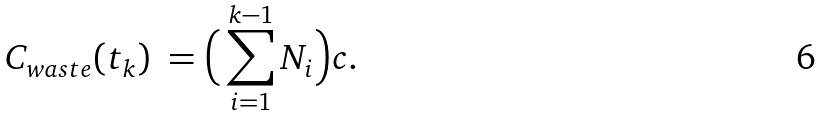Convert formula to latex. <formula><loc_0><loc_0><loc_500><loc_500>C _ { w a s t e } ( t _ { k } ) \ = \Big { ( } \sum _ { i = 1 } ^ { k - 1 } N _ { i } \Big { ) } c .</formula> 